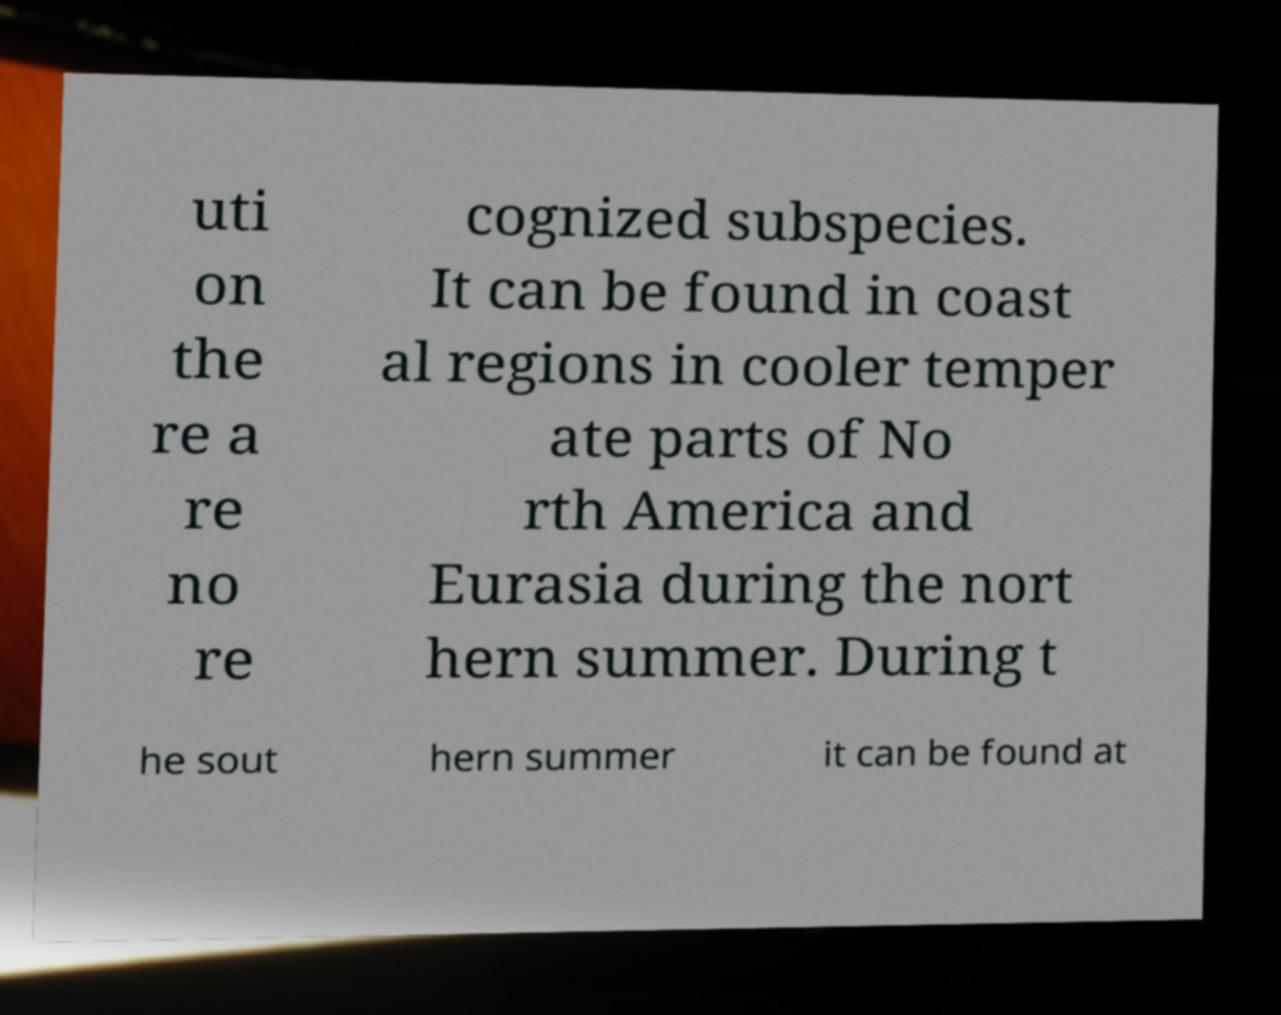Can you accurately transcribe the text from the provided image for me? uti on the re a re no re cognized subspecies. It can be found in coast al regions in cooler temper ate parts of No rth America and Eurasia during the nort hern summer. During t he sout hern summer it can be found at 